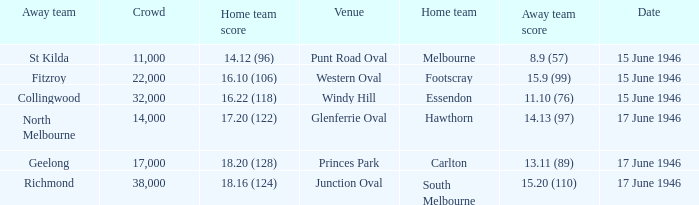On what date did a home team score 16.10 (106)? 15 June 1946. 